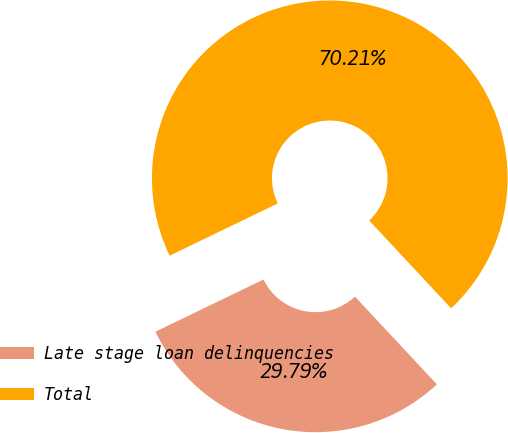<chart> <loc_0><loc_0><loc_500><loc_500><pie_chart><fcel>Late stage loan delinquencies<fcel>Total<nl><fcel>29.79%<fcel>70.21%<nl></chart> 